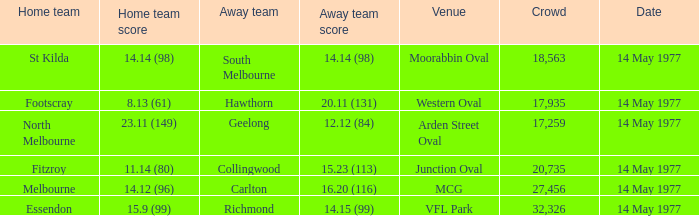Specify the visiting team against essendon. Richmond. 